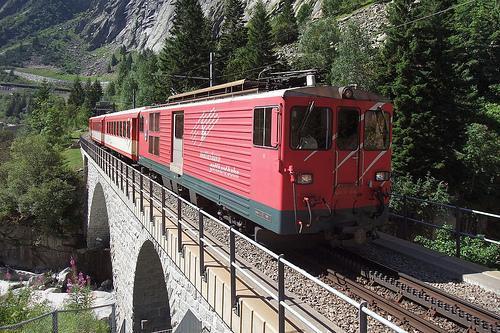How many arches in the trestle are visible?
Give a very brief answer. 2. How many windows in the front of the train?
Give a very brief answer. 3. 